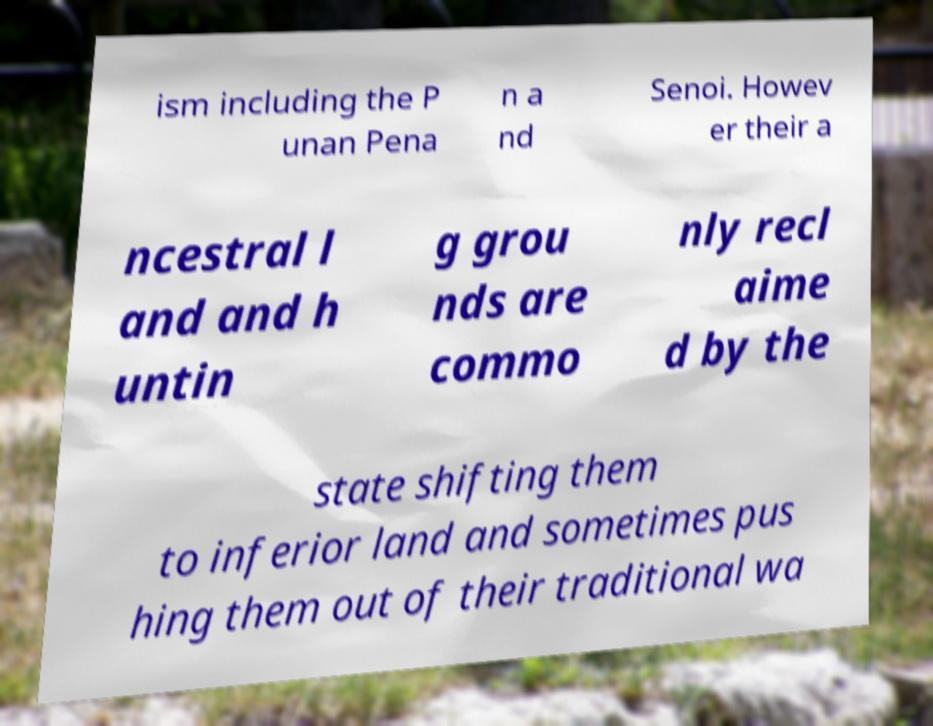For documentation purposes, I need the text within this image transcribed. Could you provide that? ism including the P unan Pena n a nd Senoi. Howev er their a ncestral l and and h untin g grou nds are commo nly recl aime d by the state shifting them to inferior land and sometimes pus hing them out of their traditional wa 